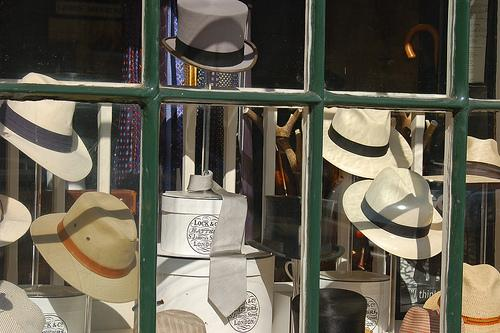Give a descriptive overview of the objects displayed in the photograph. The photo shows a collection of hats with different bands, top hats, colorful hat boxes, a necktie, and a wooden walking stick, all visible through a classic shop window. Summarize the scene in the image by mentioning the various objects displayed there. Through the shop window, we see hats with various colored bands, top hats, hat boxes, a necktie, and a wooden walking stick. Write a concise description of the primary focus in the picture. A grey top hat and tie displayed near various hats with bands and hat boxes are seen through a green-framed glass window. Provide a brief summary of the main elements in the image. Hats, tie, hat boxes, and walking stick are visible through a wooden and glass shop window, with a green frame. Explain the setting and apparent theme from the displayed items in the picture. The image presents a hat shop displaying various types of hats, hat boxes, a necktie, and a walking stick in a classic wooden-paneled store window. Mention the three most noticeable objects displayed in the picture. A grey top hat, a necktie wrapped around a pole, and multiple hat boxes can be seen through the window. Mention the accessories seen through the storefront window and the design of the window. Top hats, hats with bands, hat boxes, a necktie, and a walking stick are displayed in a wooden and glass paneled window. List the primary components in the photo. Window, hat boxes, grey top hat, black top hat, hats with bands, wooden handle walking stick, necktie. Name a few key items in the image and the setting. The image showcases hats, hat boxes, a necktie, and a walking stick displayed in a quaint old-style hat shop window. Narrate what you see in the photo in a single sentence. Different styles of hats, a tie, a walking stick, and hat boxes are displayed through a vintage wooden storefront window. 